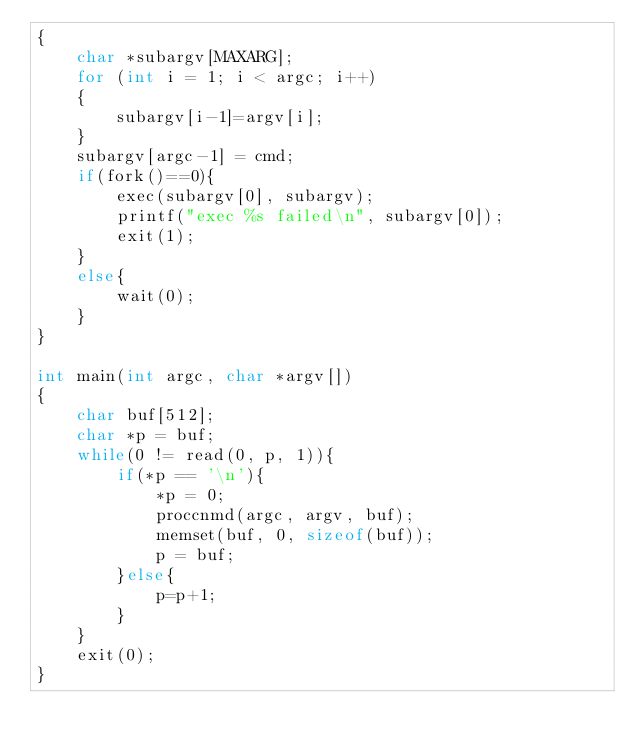Convert code to text. <code><loc_0><loc_0><loc_500><loc_500><_C_>{
    char *subargv[MAXARG];
    for (int i = 1; i < argc; i++)
    {
        subargv[i-1]=argv[i];
    }
    subargv[argc-1] = cmd;
    if(fork()==0){
        exec(subargv[0], subargv);
        printf("exec %s failed\n", subargv[0]);
        exit(1);
    }
    else{
        wait(0);
    }
}

int main(int argc, char *argv[])
{
    char buf[512];
    char *p = buf;
    while(0 != read(0, p, 1)){
        if(*p == '\n'){
            *p = 0;
            proccnmd(argc, argv, buf);
            memset(buf, 0, sizeof(buf));
            p = buf;
        }else{
            p=p+1;
        }
    }
    exit(0);
}</code> 